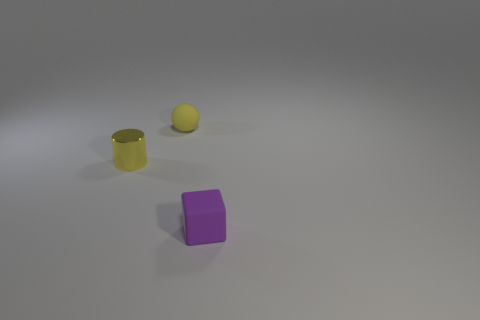Is the shape of the tiny purple rubber thing the same as the yellow matte thing? no 